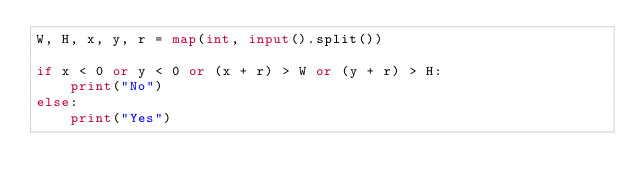Convert code to text. <code><loc_0><loc_0><loc_500><loc_500><_Python_>W, H, x, y, r = map(int, input().split())

if x < 0 or y < 0 or (x + r) > W or (y + r) > H:
    print("No")
else:
    print("Yes")
</code> 